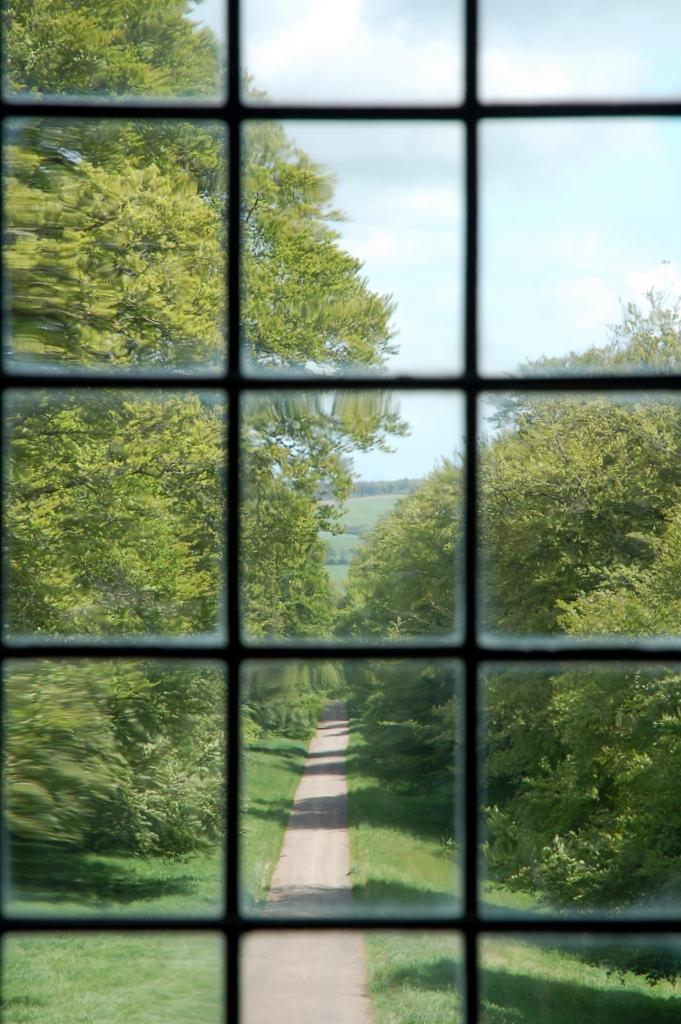What is present in the image that provides a view of the outdoors? There is a window in the image that provides a view of the outdoors. What can be seen through the window in the image? Trees are visible through the window in the image. What is visible at the top of the image? The sky is visible at the top of the image. What type of cord is being used to walk the trees in the image? There is no cord or walking involved with the trees in the image; they are simply visible through the window. 